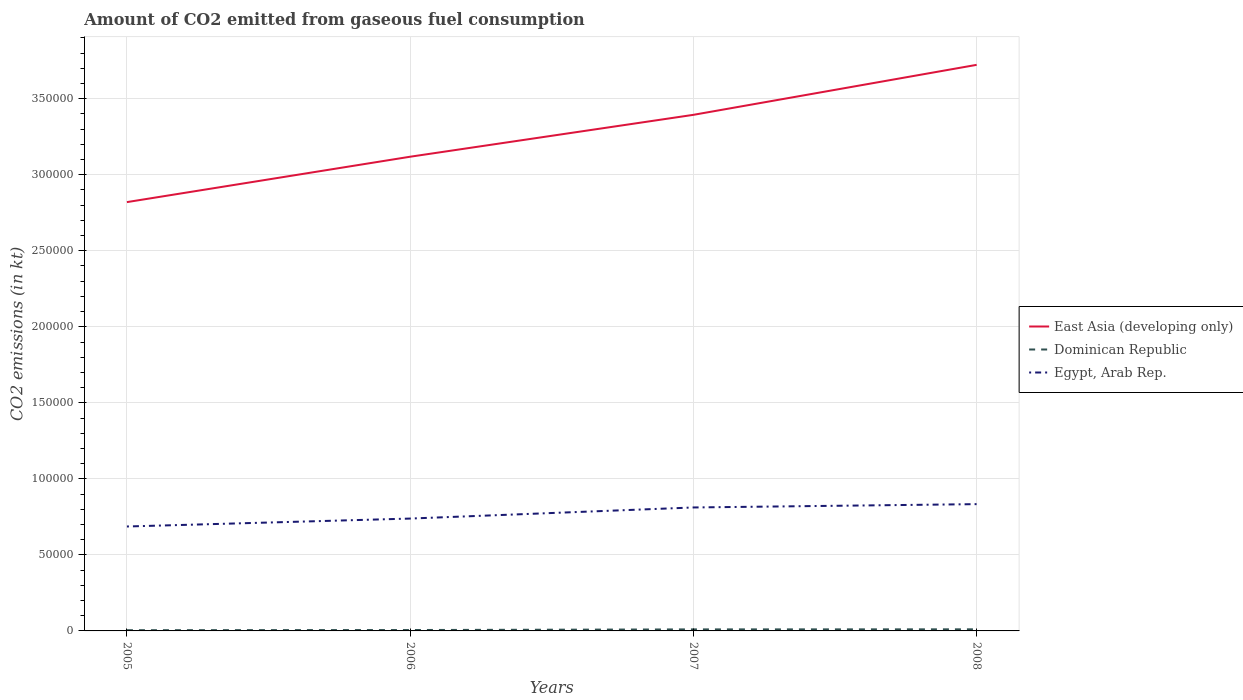Does the line corresponding to Egypt, Arab Rep. intersect with the line corresponding to East Asia (developing only)?
Provide a short and direct response. No. Across all years, what is the maximum amount of CO2 emitted in Egypt, Arab Rep.?
Offer a terse response. 6.87e+04. In which year was the amount of CO2 emitted in Dominican Republic maximum?
Provide a succinct answer. 2005. What is the total amount of CO2 emitted in East Asia (developing only) in the graph?
Your answer should be compact. -6.04e+04. What is the difference between the highest and the second highest amount of CO2 emitted in Egypt, Arab Rep.?
Your response must be concise. 1.47e+04. Is the amount of CO2 emitted in East Asia (developing only) strictly greater than the amount of CO2 emitted in Egypt, Arab Rep. over the years?
Offer a very short reply. No. How many lines are there?
Keep it short and to the point. 3. How many years are there in the graph?
Give a very brief answer. 4. Does the graph contain grids?
Your answer should be very brief. Yes. How many legend labels are there?
Keep it short and to the point. 3. How are the legend labels stacked?
Offer a very short reply. Vertical. What is the title of the graph?
Your response must be concise. Amount of CO2 emitted from gaseous fuel consumption. What is the label or title of the X-axis?
Your response must be concise. Years. What is the label or title of the Y-axis?
Ensure brevity in your answer.  CO2 emissions (in kt). What is the CO2 emissions (in kt) of East Asia (developing only) in 2005?
Ensure brevity in your answer.  2.82e+05. What is the CO2 emissions (in kt) of Dominican Republic in 2005?
Provide a short and direct response. 473.04. What is the CO2 emissions (in kt) of Egypt, Arab Rep. in 2005?
Your answer should be compact. 6.87e+04. What is the CO2 emissions (in kt) in East Asia (developing only) in 2006?
Give a very brief answer. 3.12e+05. What is the CO2 emissions (in kt) in Dominican Republic in 2006?
Your response must be concise. 590.39. What is the CO2 emissions (in kt) in Egypt, Arab Rep. in 2006?
Offer a very short reply. 7.39e+04. What is the CO2 emissions (in kt) of East Asia (developing only) in 2007?
Provide a succinct answer. 3.39e+05. What is the CO2 emissions (in kt) of Dominican Republic in 2007?
Make the answer very short. 1004.76. What is the CO2 emissions (in kt) of Egypt, Arab Rep. in 2007?
Offer a very short reply. 8.12e+04. What is the CO2 emissions (in kt) of East Asia (developing only) in 2008?
Make the answer very short. 3.72e+05. What is the CO2 emissions (in kt) in Dominican Republic in 2008?
Your answer should be very brief. 1048.76. What is the CO2 emissions (in kt) in Egypt, Arab Rep. in 2008?
Make the answer very short. 8.34e+04. Across all years, what is the maximum CO2 emissions (in kt) of East Asia (developing only)?
Give a very brief answer. 3.72e+05. Across all years, what is the maximum CO2 emissions (in kt) in Dominican Republic?
Offer a very short reply. 1048.76. Across all years, what is the maximum CO2 emissions (in kt) of Egypt, Arab Rep.?
Make the answer very short. 8.34e+04. Across all years, what is the minimum CO2 emissions (in kt) of East Asia (developing only)?
Offer a terse response. 2.82e+05. Across all years, what is the minimum CO2 emissions (in kt) in Dominican Republic?
Make the answer very short. 473.04. Across all years, what is the minimum CO2 emissions (in kt) of Egypt, Arab Rep.?
Your answer should be very brief. 6.87e+04. What is the total CO2 emissions (in kt) in East Asia (developing only) in the graph?
Offer a very short reply. 1.31e+06. What is the total CO2 emissions (in kt) in Dominican Republic in the graph?
Give a very brief answer. 3116.95. What is the total CO2 emissions (in kt) of Egypt, Arab Rep. in the graph?
Your answer should be very brief. 3.07e+05. What is the difference between the CO2 emissions (in kt) of East Asia (developing only) in 2005 and that in 2006?
Your answer should be very brief. -2.99e+04. What is the difference between the CO2 emissions (in kt) of Dominican Republic in 2005 and that in 2006?
Make the answer very short. -117.34. What is the difference between the CO2 emissions (in kt) in Egypt, Arab Rep. in 2005 and that in 2006?
Make the answer very short. -5214.47. What is the difference between the CO2 emissions (in kt) of East Asia (developing only) in 2005 and that in 2007?
Offer a terse response. -5.74e+04. What is the difference between the CO2 emissions (in kt) in Dominican Republic in 2005 and that in 2007?
Ensure brevity in your answer.  -531.72. What is the difference between the CO2 emissions (in kt) of Egypt, Arab Rep. in 2005 and that in 2007?
Make the answer very short. -1.25e+04. What is the difference between the CO2 emissions (in kt) in East Asia (developing only) in 2005 and that in 2008?
Your answer should be very brief. -9.03e+04. What is the difference between the CO2 emissions (in kt) of Dominican Republic in 2005 and that in 2008?
Provide a succinct answer. -575.72. What is the difference between the CO2 emissions (in kt) of Egypt, Arab Rep. in 2005 and that in 2008?
Keep it short and to the point. -1.47e+04. What is the difference between the CO2 emissions (in kt) in East Asia (developing only) in 2006 and that in 2007?
Offer a very short reply. -2.75e+04. What is the difference between the CO2 emissions (in kt) in Dominican Republic in 2006 and that in 2007?
Give a very brief answer. -414.37. What is the difference between the CO2 emissions (in kt) in Egypt, Arab Rep. in 2006 and that in 2007?
Your answer should be compact. -7301. What is the difference between the CO2 emissions (in kt) in East Asia (developing only) in 2006 and that in 2008?
Keep it short and to the point. -6.04e+04. What is the difference between the CO2 emissions (in kt) of Dominican Republic in 2006 and that in 2008?
Keep it short and to the point. -458.38. What is the difference between the CO2 emissions (in kt) in Egypt, Arab Rep. in 2006 and that in 2008?
Your answer should be compact. -9486.53. What is the difference between the CO2 emissions (in kt) in East Asia (developing only) in 2007 and that in 2008?
Make the answer very short. -3.29e+04. What is the difference between the CO2 emissions (in kt) in Dominican Republic in 2007 and that in 2008?
Offer a terse response. -44. What is the difference between the CO2 emissions (in kt) of Egypt, Arab Rep. in 2007 and that in 2008?
Your answer should be compact. -2185.53. What is the difference between the CO2 emissions (in kt) of East Asia (developing only) in 2005 and the CO2 emissions (in kt) of Dominican Republic in 2006?
Offer a terse response. 2.81e+05. What is the difference between the CO2 emissions (in kt) in East Asia (developing only) in 2005 and the CO2 emissions (in kt) in Egypt, Arab Rep. in 2006?
Your answer should be very brief. 2.08e+05. What is the difference between the CO2 emissions (in kt) in Dominican Republic in 2005 and the CO2 emissions (in kt) in Egypt, Arab Rep. in 2006?
Make the answer very short. -7.34e+04. What is the difference between the CO2 emissions (in kt) in East Asia (developing only) in 2005 and the CO2 emissions (in kt) in Dominican Republic in 2007?
Ensure brevity in your answer.  2.81e+05. What is the difference between the CO2 emissions (in kt) of East Asia (developing only) in 2005 and the CO2 emissions (in kt) of Egypt, Arab Rep. in 2007?
Make the answer very short. 2.01e+05. What is the difference between the CO2 emissions (in kt) of Dominican Republic in 2005 and the CO2 emissions (in kt) of Egypt, Arab Rep. in 2007?
Ensure brevity in your answer.  -8.07e+04. What is the difference between the CO2 emissions (in kt) in East Asia (developing only) in 2005 and the CO2 emissions (in kt) in Dominican Republic in 2008?
Provide a short and direct response. 2.81e+05. What is the difference between the CO2 emissions (in kt) of East Asia (developing only) in 2005 and the CO2 emissions (in kt) of Egypt, Arab Rep. in 2008?
Your response must be concise. 1.99e+05. What is the difference between the CO2 emissions (in kt) of Dominican Republic in 2005 and the CO2 emissions (in kt) of Egypt, Arab Rep. in 2008?
Make the answer very short. -8.29e+04. What is the difference between the CO2 emissions (in kt) of East Asia (developing only) in 2006 and the CO2 emissions (in kt) of Dominican Republic in 2007?
Make the answer very short. 3.11e+05. What is the difference between the CO2 emissions (in kt) in East Asia (developing only) in 2006 and the CO2 emissions (in kt) in Egypt, Arab Rep. in 2007?
Offer a very short reply. 2.31e+05. What is the difference between the CO2 emissions (in kt) of Dominican Republic in 2006 and the CO2 emissions (in kt) of Egypt, Arab Rep. in 2007?
Give a very brief answer. -8.06e+04. What is the difference between the CO2 emissions (in kt) of East Asia (developing only) in 2006 and the CO2 emissions (in kt) of Dominican Republic in 2008?
Ensure brevity in your answer.  3.11e+05. What is the difference between the CO2 emissions (in kt) in East Asia (developing only) in 2006 and the CO2 emissions (in kt) in Egypt, Arab Rep. in 2008?
Ensure brevity in your answer.  2.28e+05. What is the difference between the CO2 emissions (in kt) of Dominican Republic in 2006 and the CO2 emissions (in kt) of Egypt, Arab Rep. in 2008?
Give a very brief answer. -8.28e+04. What is the difference between the CO2 emissions (in kt) of East Asia (developing only) in 2007 and the CO2 emissions (in kt) of Dominican Republic in 2008?
Ensure brevity in your answer.  3.38e+05. What is the difference between the CO2 emissions (in kt) of East Asia (developing only) in 2007 and the CO2 emissions (in kt) of Egypt, Arab Rep. in 2008?
Your response must be concise. 2.56e+05. What is the difference between the CO2 emissions (in kt) in Dominican Republic in 2007 and the CO2 emissions (in kt) in Egypt, Arab Rep. in 2008?
Keep it short and to the point. -8.24e+04. What is the average CO2 emissions (in kt) of East Asia (developing only) per year?
Keep it short and to the point. 3.26e+05. What is the average CO2 emissions (in kt) in Dominican Republic per year?
Give a very brief answer. 779.24. What is the average CO2 emissions (in kt) in Egypt, Arab Rep. per year?
Your answer should be compact. 7.68e+04. In the year 2005, what is the difference between the CO2 emissions (in kt) in East Asia (developing only) and CO2 emissions (in kt) in Dominican Republic?
Your answer should be very brief. 2.82e+05. In the year 2005, what is the difference between the CO2 emissions (in kt) in East Asia (developing only) and CO2 emissions (in kt) in Egypt, Arab Rep.?
Provide a succinct answer. 2.13e+05. In the year 2005, what is the difference between the CO2 emissions (in kt) of Dominican Republic and CO2 emissions (in kt) of Egypt, Arab Rep.?
Your response must be concise. -6.82e+04. In the year 2006, what is the difference between the CO2 emissions (in kt) of East Asia (developing only) and CO2 emissions (in kt) of Dominican Republic?
Keep it short and to the point. 3.11e+05. In the year 2006, what is the difference between the CO2 emissions (in kt) in East Asia (developing only) and CO2 emissions (in kt) in Egypt, Arab Rep.?
Give a very brief answer. 2.38e+05. In the year 2006, what is the difference between the CO2 emissions (in kt) of Dominican Republic and CO2 emissions (in kt) of Egypt, Arab Rep.?
Your answer should be very brief. -7.33e+04. In the year 2007, what is the difference between the CO2 emissions (in kt) in East Asia (developing only) and CO2 emissions (in kt) in Dominican Republic?
Offer a very short reply. 3.38e+05. In the year 2007, what is the difference between the CO2 emissions (in kt) in East Asia (developing only) and CO2 emissions (in kt) in Egypt, Arab Rep.?
Ensure brevity in your answer.  2.58e+05. In the year 2007, what is the difference between the CO2 emissions (in kt) of Dominican Republic and CO2 emissions (in kt) of Egypt, Arab Rep.?
Offer a very short reply. -8.02e+04. In the year 2008, what is the difference between the CO2 emissions (in kt) in East Asia (developing only) and CO2 emissions (in kt) in Dominican Republic?
Offer a terse response. 3.71e+05. In the year 2008, what is the difference between the CO2 emissions (in kt) of East Asia (developing only) and CO2 emissions (in kt) of Egypt, Arab Rep.?
Offer a very short reply. 2.89e+05. In the year 2008, what is the difference between the CO2 emissions (in kt) of Dominican Republic and CO2 emissions (in kt) of Egypt, Arab Rep.?
Your response must be concise. -8.23e+04. What is the ratio of the CO2 emissions (in kt) of East Asia (developing only) in 2005 to that in 2006?
Ensure brevity in your answer.  0.9. What is the ratio of the CO2 emissions (in kt) of Dominican Republic in 2005 to that in 2006?
Your answer should be very brief. 0.8. What is the ratio of the CO2 emissions (in kt) of Egypt, Arab Rep. in 2005 to that in 2006?
Provide a succinct answer. 0.93. What is the ratio of the CO2 emissions (in kt) of East Asia (developing only) in 2005 to that in 2007?
Make the answer very short. 0.83. What is the ratio of the CO2 emissions (in kt) in Dominican Republic in 2005 to that in 2007?
Make the answer very short. 0.47. What is the ratio of the CO2 emissions (in kt) in Egypt, Arab Rep. in 2005 to that in 2007?
Give a very brief answer. 0.85. What is the ratio of the CO2 emissions (in kt) of East Asia (developing only) in 2005 to that in 2008?
Make the answer very short. 0.76. What is the ratio of the CO2 emissions (in kt) in Dominican Republic in 2005 to that in 2008?
Ensure brevity in your answer.  0.45. What is the ratio of the CO2 emissions (in kt) in Egypt, Arab Rep. in 2005 to that in 2008?
Your answer should be very brief. 0.82. What is the ratio of the CO2 emissions (in kt) in East Asia (developing only) in 2006 to that in 2007?
Your answer should be compact. 0.92. What is the ratio of the CO2 emissions (in kt) in Dominican Republic in 2006 to that in 2007?
Give a very brief answer. 0.59. What is the ratio of the CO2 emissions (in kt) of Egypt, Arab Rep. in 2006 to that in 2007?
Provide a short and direct response. 0.91. What is the ratio of the CO2 emissions (in kt) of East Asia (developing only) in 2006 to that in 2008?
Your answer should be very brief. 0.84. What is the ratio of the CO2 emissions (in kt) in Dominican Republic in 2006 to that in 2008?
Keep it short and to the point. 0.56. What is the ratio of the CO2 emissions (in kt) in Egypt, Arab Rep. in 2006 to that in 2008?
Provide a short and direct response. 0.89. What is the ratio of the CO2 emissions (in kt) of East Asia (developing only) in 2007 to that in 2008?
Provide a succinct answer. 0.91. What is the ratio of the CO2 emissions (in kt) in Dominican Republic in 2007 to that in 2008?
Your answer should be compact. 0.96. What is the ratio of the CO2 emissions (in kt) of Egypt, Arab Rep. in 2007 to that in 2008?
Make the answer very short. 0.97. What is the difference between the highest and the second highest CO2 emissions (in kt) in East Asia (developing only)?
Offer a very short reply. 3.29e+04. What is the difference between the highest and the second highest CO2 emissions (in kt) in Dominican Republic?
Your answer should be very brief. 44. What is the difference between the highest and the second highest CO2 emissions (in kt) of Egypt, Arab Rep.?
Ensure brevity in your answer.  2185.53. What is the difference between the highest and the lowest CO2 emissions (in kt) of East Asia (developing only)?
Offer a very short reply. 9.03e+04. What is the difference between the highest and the lowest CO2 emissions (in kt) of Dominican Republic?
Your answer should be very brief. 575.72. What is the difference between the highest and the lowest CO2 emissions (in kt) in Egypt, Arab Rep.?
Offer a very short reply. 1.47e+04. 